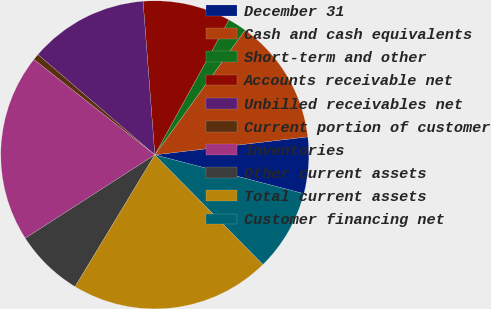Convert chart to OTSL. <chart><loc_0><loc_0><loc_500><loc_500><pie_chart><fcel>December 31<fcel>Cash and cash equivalents<fcel>Short-term and other<fcel>Accounts receivable net<fcel>Unbilled receivables net<fcel>Current portion of customer<fcel>Inventories<fcel>Other current assets<fcel>Total current assets<fcel>Customer financing net<nl><fcel>5.92%<fcel>13.16%<fcel>1.98%<fcel>9.21%<fcel>12.5%<fcel>0.66%<fcel>19.73%<fcel>7.24%<fcel>21.05%<fcel>8.55%<nl></chart> 